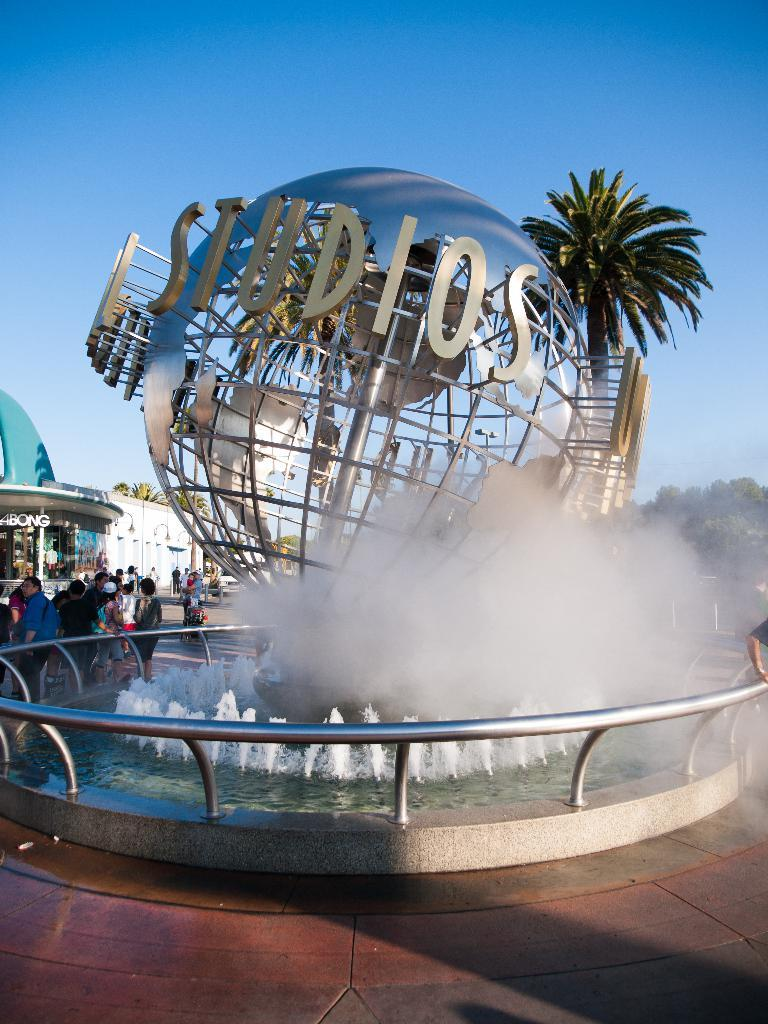What is the main feature in the image? There is a water fountain in the image. Are there any people in the image? Yes, there are persons in the image. What type of natural elements can be seen in the image? There are trees in the image. What type of structure is visible in the image? There is a building in the image. What can be seen in the background of the image? The sky is visible in the background of the image. What advice do the girls in the image give to the person shaking the tree? There are no girls present in the image, and no one is shaking a tree. 